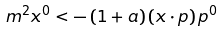Convert formula to latex. <formula><loc_0><loc_0><loc_500><loc_500>m ^ { 2 } x ^ { 0 } < - \left ( 1 + a \right ) \left ( x \cdot p \right ) p ^ { 0 }</formula> 